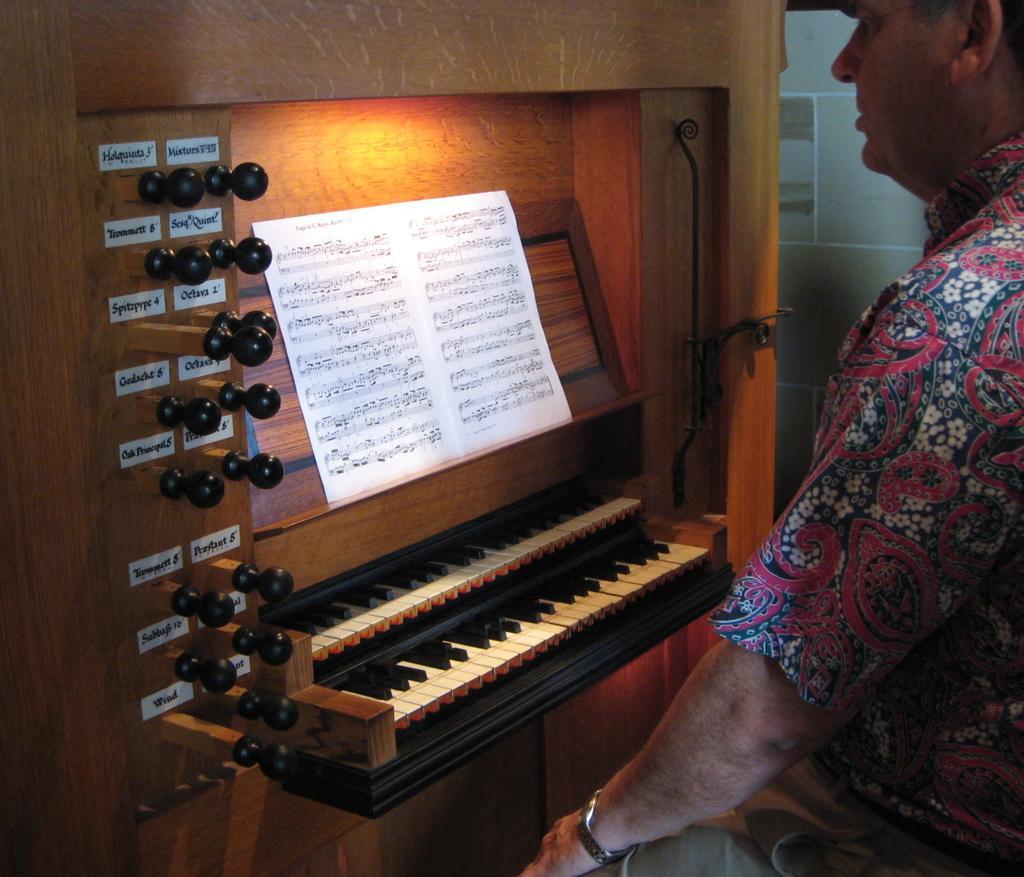How would you summarize this image in a sentence or two? In this image we can see a person sitting in front of a keyboard above it there is a sheet which consists musical nodes and on the left side of the image there are a few objects with name places on it. 